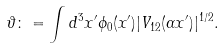Convert formula to latex. <formula><loc_0><loc_0><loc_500><loc_500>\vartheta \colon = \int d ^ { 3 } x ^ { \prime } \phi _ { 0 } ( x ^ { \prime } ) | V _ { 1 2 } ( \alpha x ^ { \prime } ) | ^ { 1 / 2 } .</formula> 